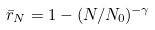Convert formula to latex. <formula><loc_0><loc_0><loc_500><loc_500>\bar { r } _ { N } = 1 - ( N / N _ { 0 } ) ^ { - \gamma }</formula> 